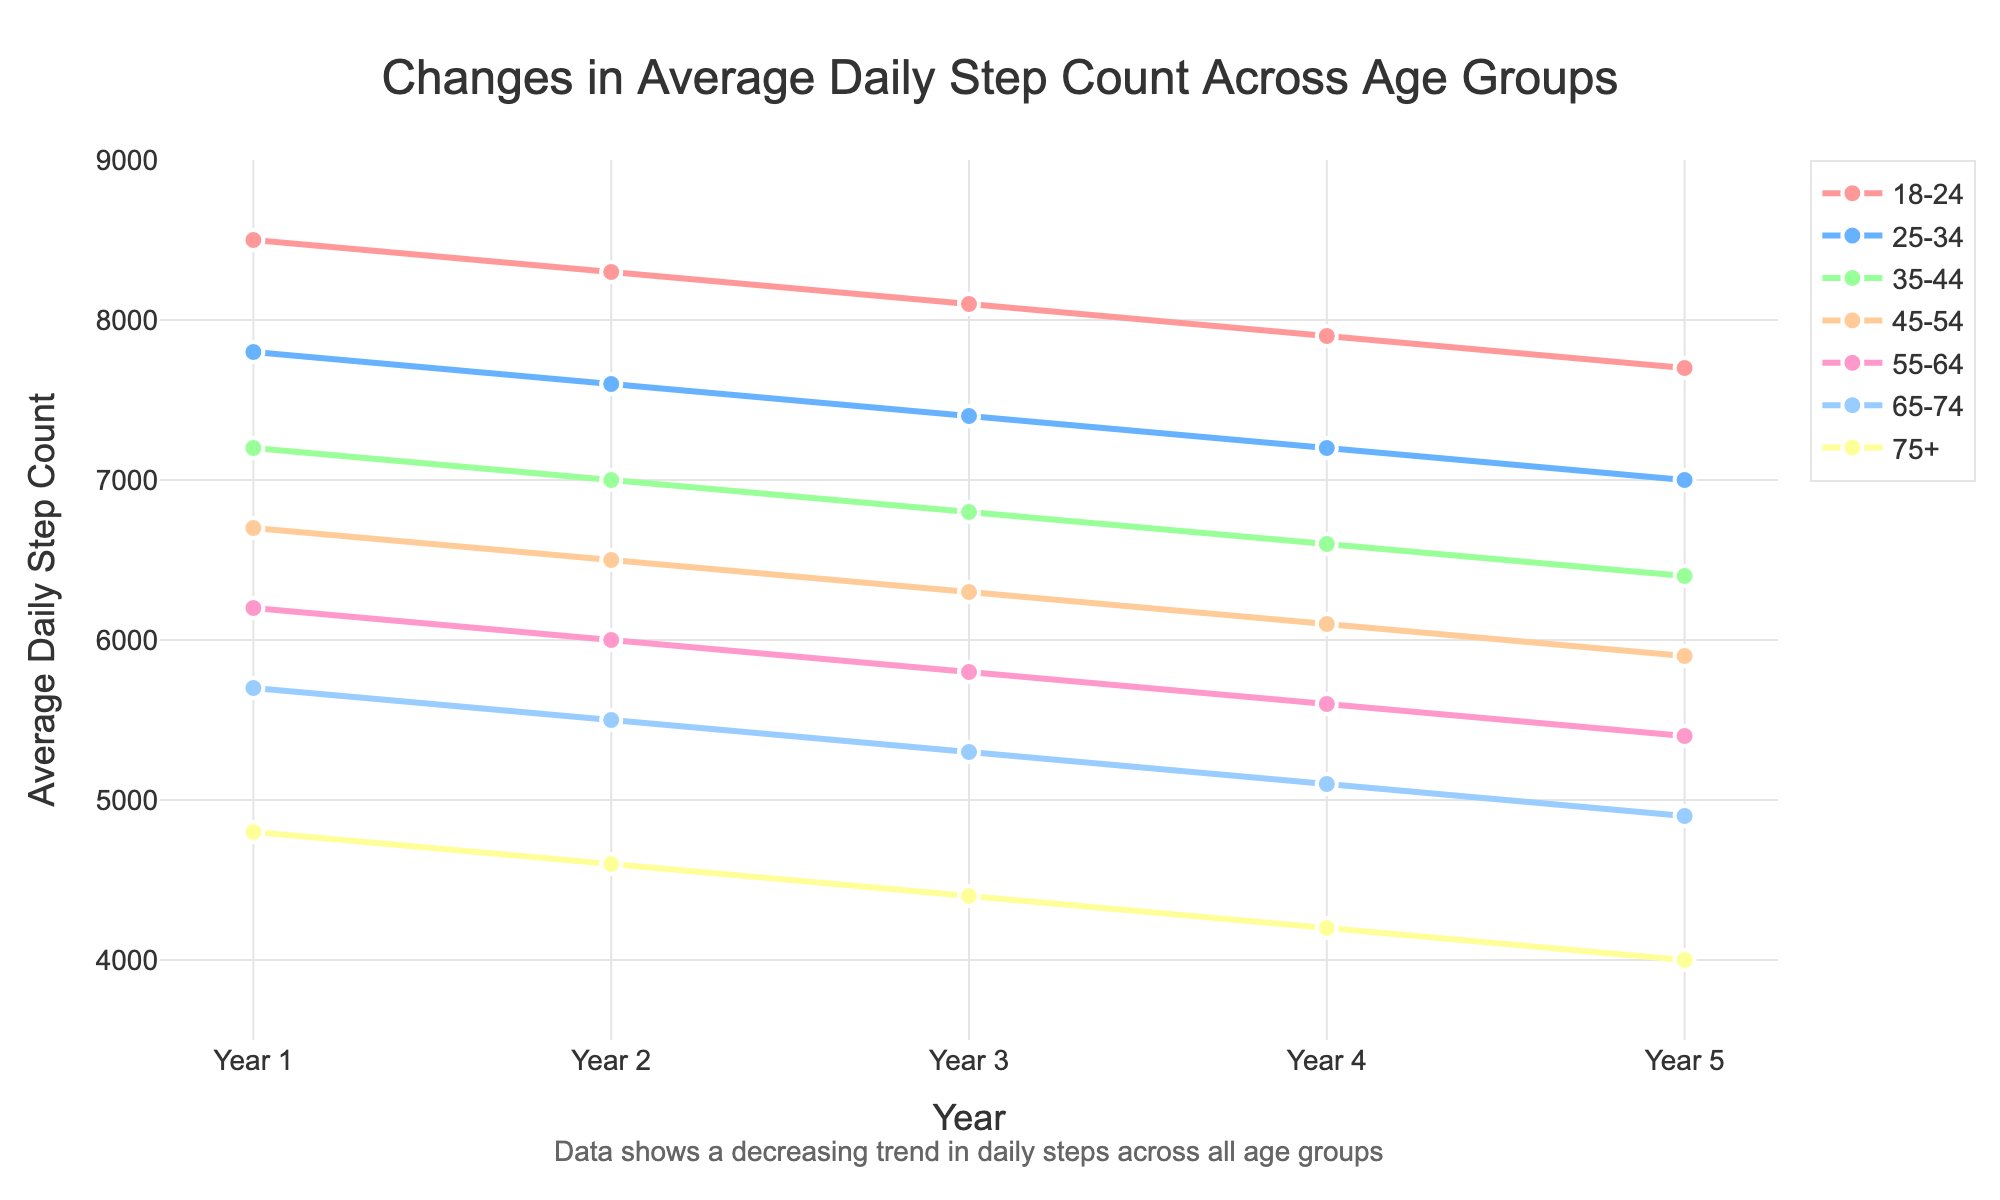What general trend do you notice in the step counts across all age groups from Year 1 to Year 5? The general trend across all age groups shows a decrease in average daily step count from Year 1 to Year 5. This can be seen by the downward sloping lines for each age group.
Answer: Decreasing Which age group had the highest average daily step count in Year 1? According to the figure, the "18-24" age group had the highest average daily step count in Year 1, represented by the topmost line on the left side of the graph.
Answer: 18-24 What is the difference in the average daily step count between the "18-24" and "75+" age groups in Year 5? Subtract the average daily step count of the "75+" age group from the "18-24" age group in Year 5: 7700 (18-24) - 4000 (75+).
Answer: 3700 Which age group experienced the largest decrease in average daily step count over the 5-year period? Calculate the change for each age group from Year 1 to Year 5 and determine the one with the largest decrease. For example, for "18-24": 8500 - 7700 = 800. Repeat for all groups and compare.
Answer: 75+ In Year 3, which age group has a higher average daily step count, "35-44" or "55-64"? Compare the values of the "35-44" and "55-64" age groups in Year 3 from the chart. "35-44" has 6800 and "55-64" has 5800.
Answer: 35-44 Which year had the smallest difference in average daily step count between the "25-34" and "65-74" age groups? Calculate the difference in each year: (25-34) - (65-74); they are: Year 1: 2100, Year 2: 2100, Year 3: 2100, Year 4: 2100, Year 5: 2100. The difference is constant.
Answer: Year 1 to Year 5 If we average the daily step counts across all age groups in Year 4, what is the result? Sum the average daily step count for all age groups in Year 4 and divide by the number of age groups. (7900 + 7200 + 6600 + 6100 + 5600 + 5100 + 4200) / 7.
Answer: 6100 How do the slopes of the lines for younger age groups (e.g., 18-24) compare to older age groups (e.g., 75+), and what does this indicate about their activity levels over the years? The slope for "18-24" is less steep compared to the "75+" group, indicating a slower decline in activity levels for younger individuals over the years compared to older individuals.
Answer: Slower decline Which age group had nearly the same average daily step count as the "65-74" age group in Year 2? Compare the "65-74" age group's data in Year 2 with other age groups. "75+" had 4600, which is close to "65-74"'s 5500.
Answer: None By how much did the average daily step count for the "25-34" age group change from Year 2 to Year 3? Subtract the value in Year 3 from Year 2 for the "25-34" age group: 7400 (Year 3) - 7600 (Year 2).
Answer: 200 